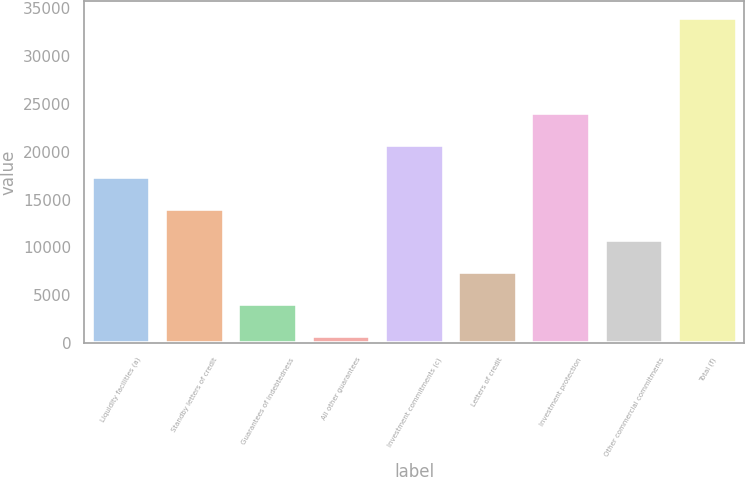Convert chart to OTSL. <chart><loc_0><loc_0><loc_500><loc_500><bar_chart><fcel>Liquidity facilities (a)<fcel>Standby letters of credit<fcel>Guarantees of indebtedness<fcel>All other guarantees<fcel>Investment commitments (c)<fcel>Letters of credit<fcel>Investment protection<fcel>Other commercial commitments<fcel>Total (f)<nl><fcel>17369<fcel>14048.6<fcel>4087.4<fcel>767<fcel>20689.4<fcel>7407.8<fcel>24009.8<fcel>10728.2<fcel>33971<nl></chart> 